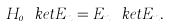<formula> <loc_0><loc_0><loc_500><loc_500>H _ { 0 } \ k e t { E _ { n } } = E _ { n } \ k e t { E _ { n } } .</formula> 